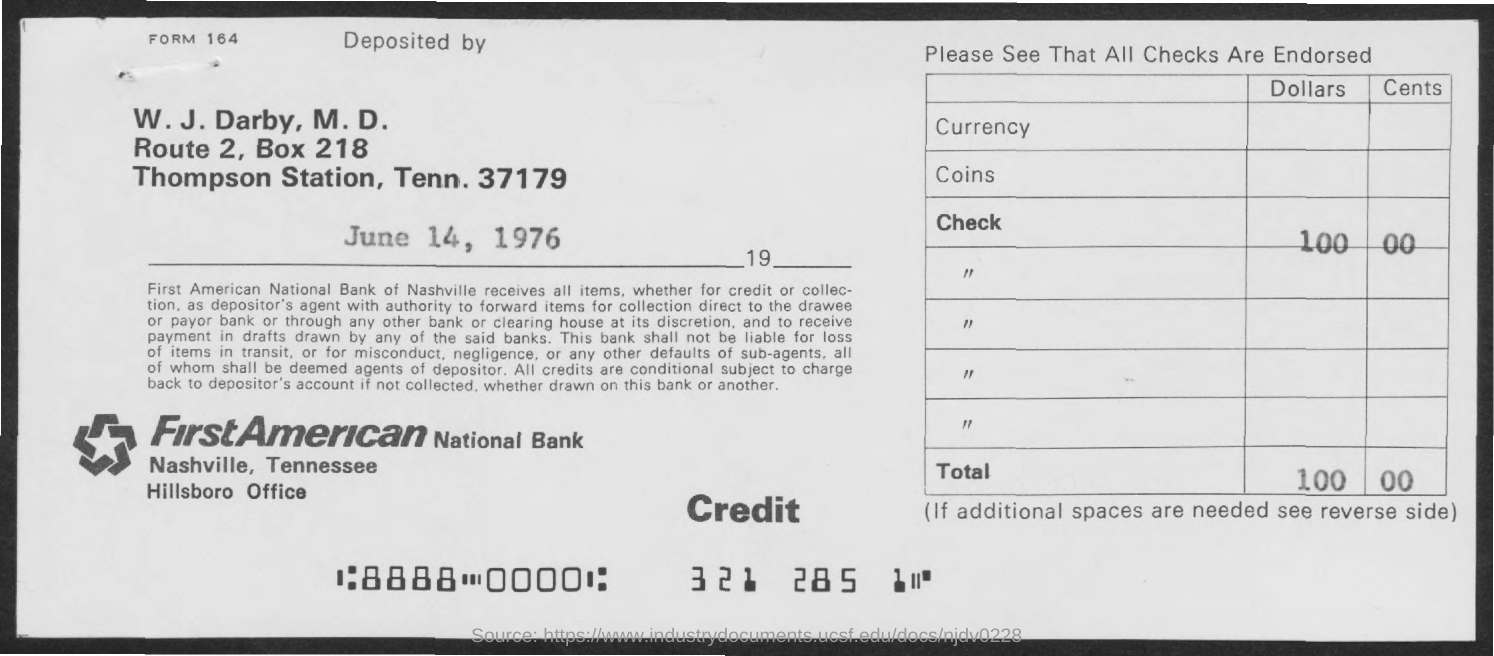Indicate a few pertinent items in this graphic. The deposit date provided in the form is June 14, 1976. Dr. W. J. Darby has deposited the check amount. 